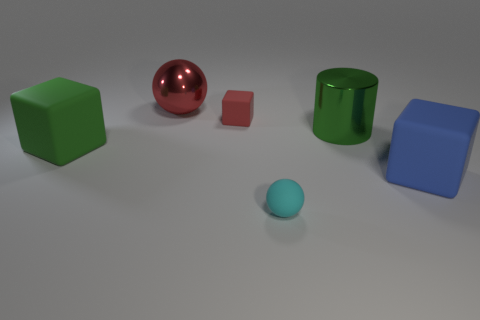Add 2 small purple spheres. How many objects exist? 8 Subtract all balls. How many objects are left? 4 Subtract all green rubber balls. Subtract all metal cylinders. How many objects are left? 5 Add 3 cyan balls. How many cyan balls are left? 4 Add 5 large red metallic spheres. How many large red metallic spheres exist? 6 Subtract 0 cyan cylinders. How many objects are left? 6 